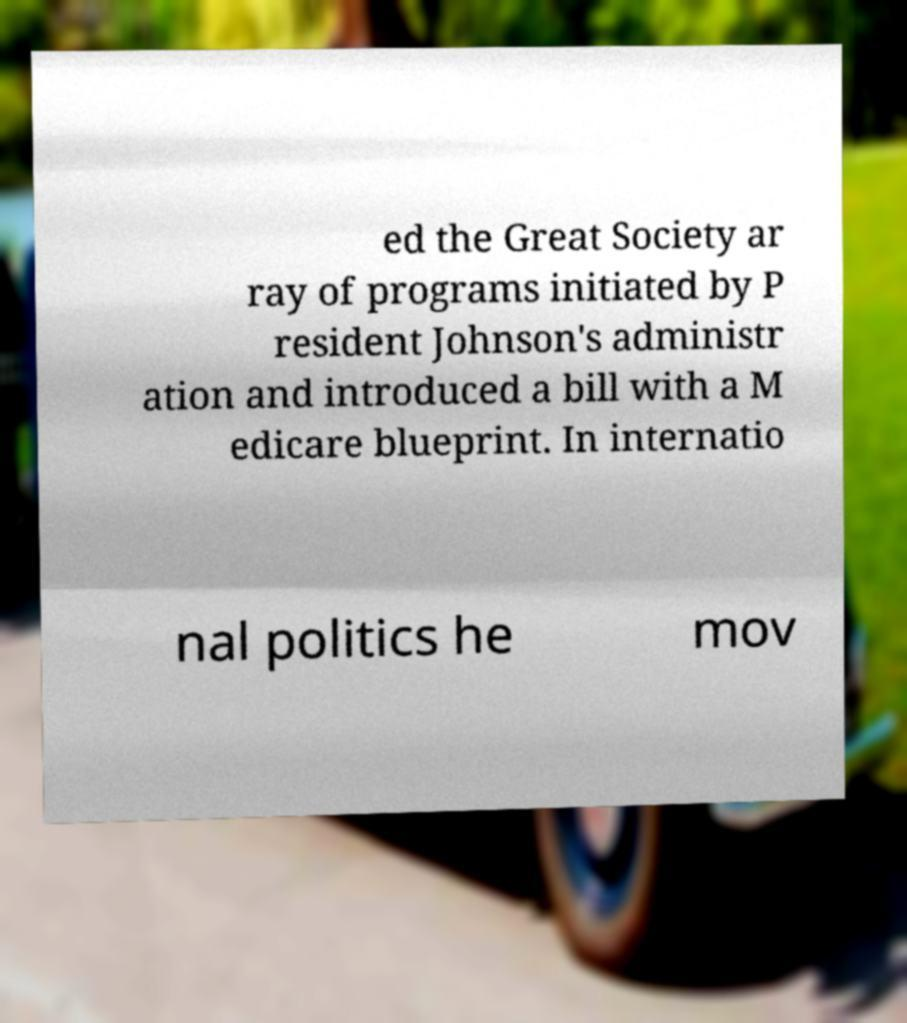Can you accurately transcribe the text from the provided image for me? ed the Great Society ar ray of programs initiated by P resident Johnson's administr ation and introduced a bill with a M edicare blueprint. In internatio nal politics he mov 